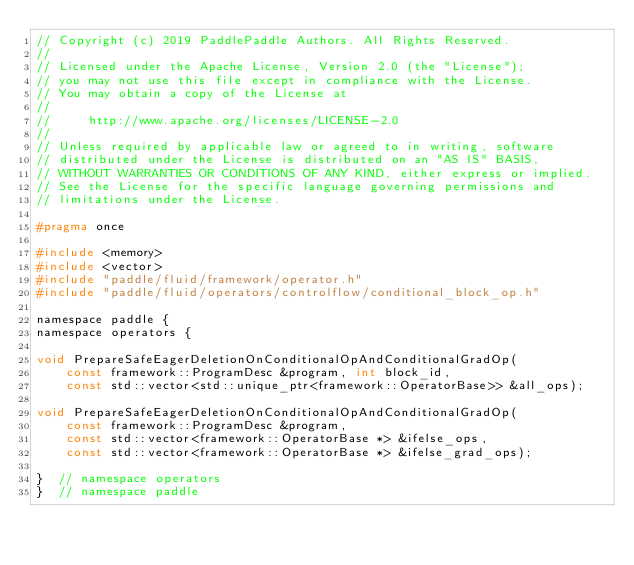Convert code to text. <code><loc_0><loc_0><loc_500><loc_500><_C_>// Copyright (c) 2019 PaddlePaddle Authors. All Rights Reserved.
//
// Licensed under the Apache License, Version 2.0 (the "License");
// you may not use this file except in compliance with the License.
// You may obtain a copy of the License at
//
//     http://www.apache.org/licenses/LICENSE-2.0
//
// Unless required by applicable law or agreed to in writing, software
// distributed under the License is distributed on an "AS IS" BASIS,
// WITHOUT WARRANTIES OR CONDITIONS OF ANY KIND, either express or implied.
// See the License for the specific language governing permissions and
// limitations under the License.

#pragma once

#include <memory>
#include <vector>
#include "paddle/fluid/framework/operator.h"
#include "paddle/fluid/operators/controlflow/conditional_block_op.h"

namespace paddle {
namespace operators {

void PrepareSafeEagerDeletionOnConditionalOpAndConditionalGradOp(
    const framework::ProgramDesc &program, int block_id,
    const std::vector<std::unique_ptr<framework::OperatorBase>> &all_ops);

void PrepareSafeEagerDeletionOnConditionalOpAndConditionalGradOp(
    const framework::ProgramDesc &program,
    const std::vector<framework::OperatorBase *> &ifelse_ops,
    const std::vector<framework::OperatorBase *> &ifelse_grad_ops);

}  // namespace operators
}  // namespace paddle
</code> 